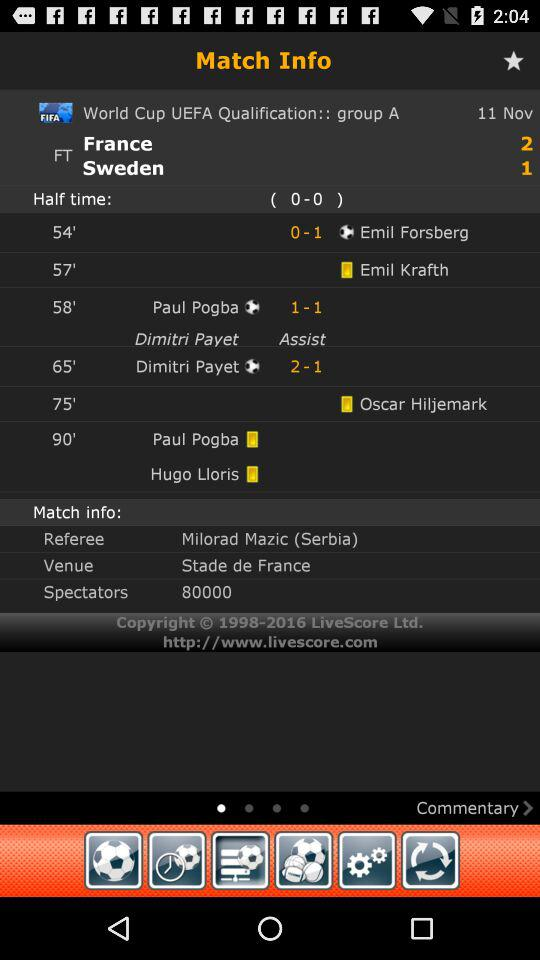How many spectators are shown here? There are 80000 spectators. 